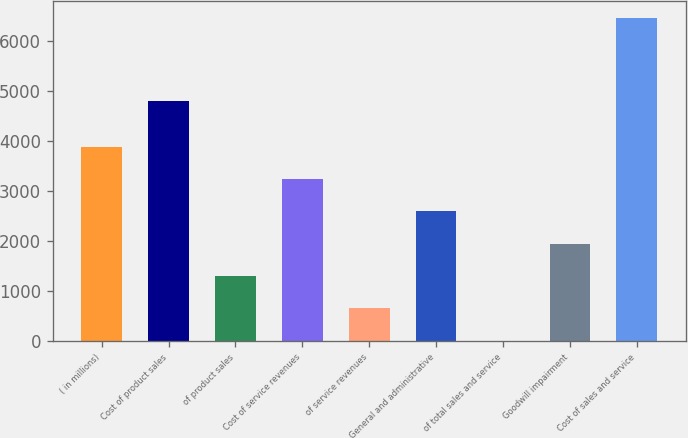Convert chart to OTSL. <chart><loc_0><loc_0><loc_500><loc_500><bar_chart><fcel>( in millions)<fcel>Cost of product sales<fcel>of product sales<fcel>Cost of service revenues<fcel>of service revenues<fcel>General and administrative<fcel>of total sales and service<fcel>Goodwill impairment<fcel>Cost of sales and service<nl><fcel>3882.8<fcel>4794<fcel>1300.6<fcel>3237.25<fcel>655.05<fcel>2591.7<fcel>9.5<fcel>1946.15<fcel>6465<nl></chart> 